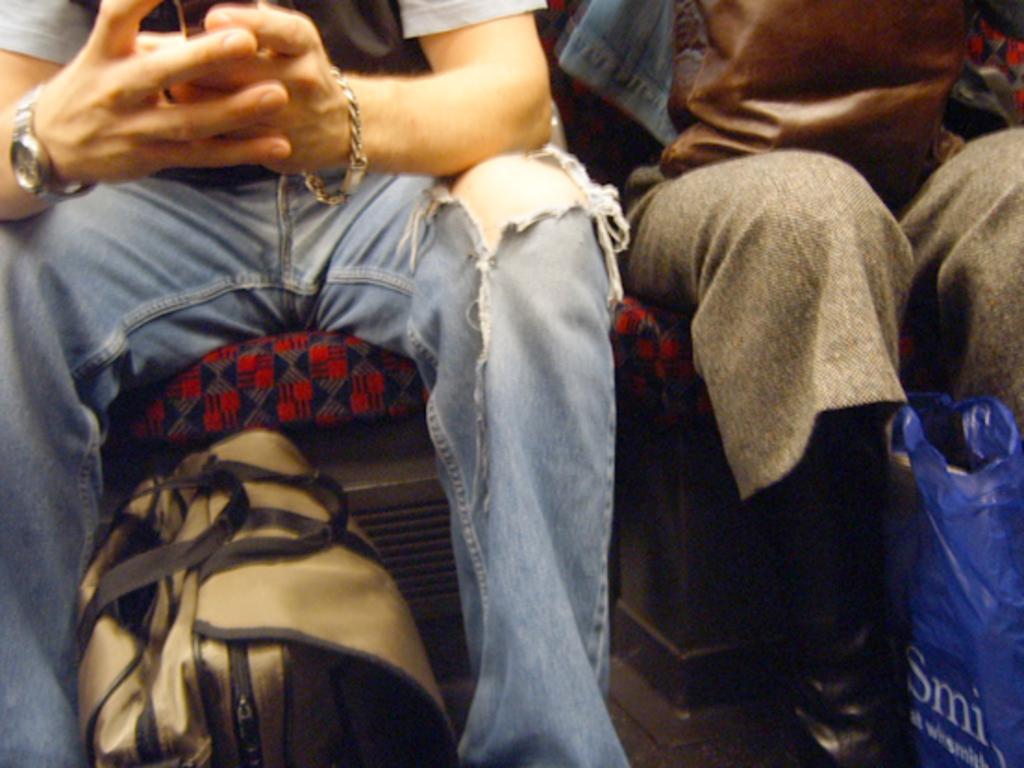Please provide a concise description of this image. In this image we can see two people sitting on the chairs. In that a person is holding a cellphone. We can also see a bag and a cover beside them. 